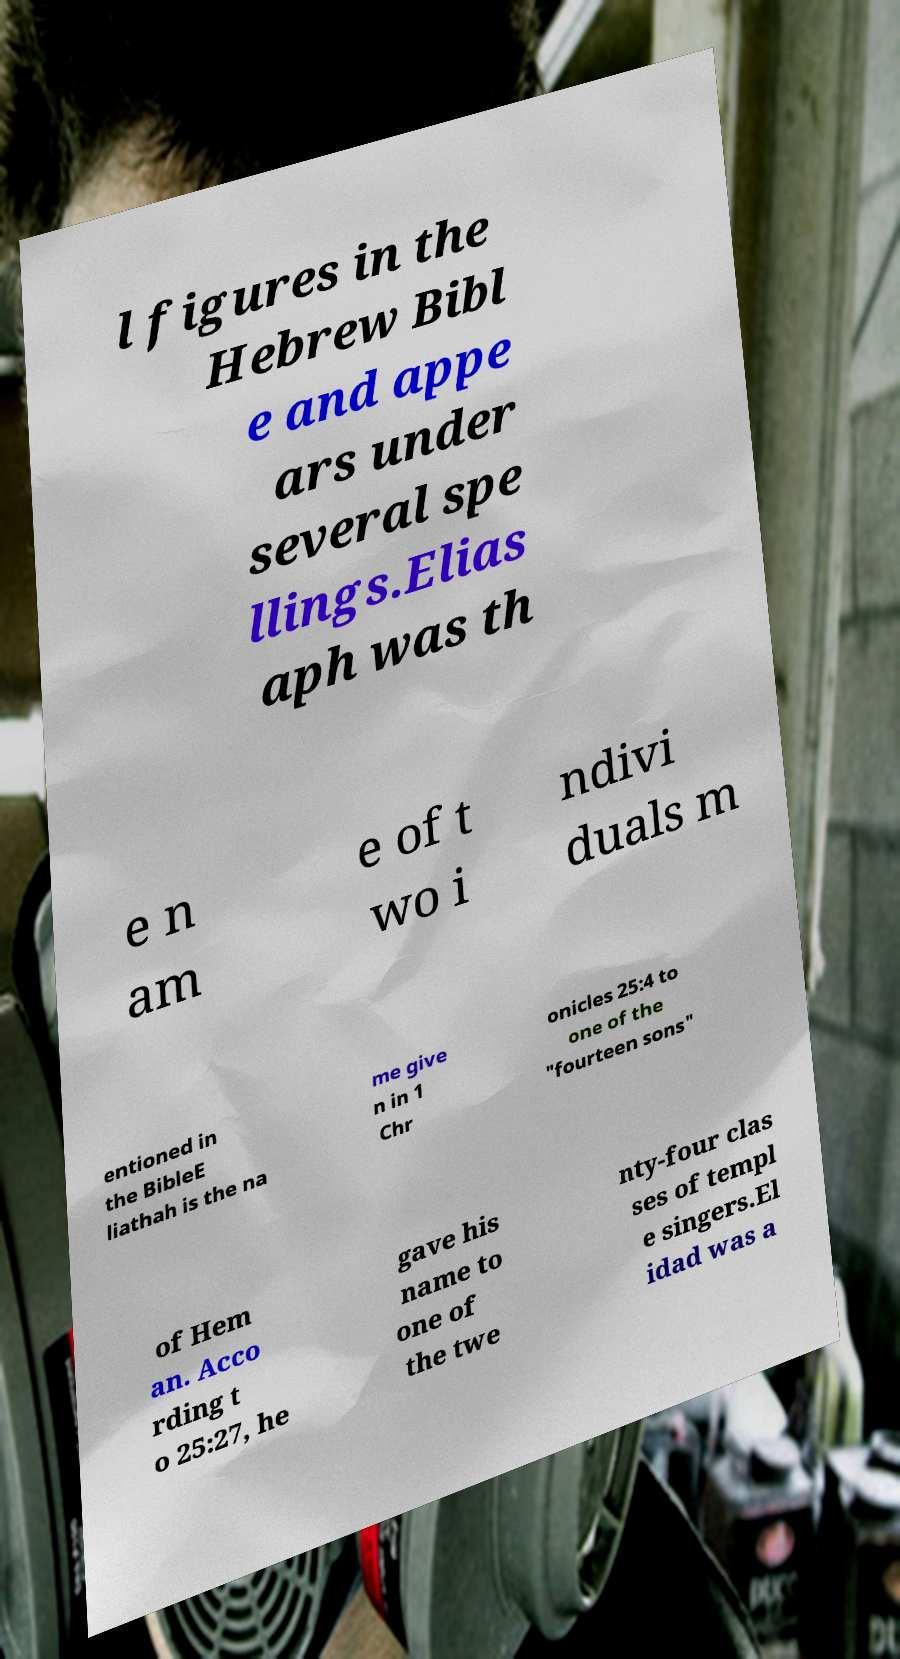Please read and relay the text visible in this image. What does it say? l figures in the Hebrew Bibl e and appe ars under several spe llings.Elias aph was th e n am e of t wo i ndivi duals m entioned in the BibleE liathah is the na me give n in 1 Chr onicles 25:4 to one of the "fourteen sons" of Hem an. Acco rding t o 25:27, he gave his name to one of the twe nty-four clas ses of templ e singers.El idad was a 